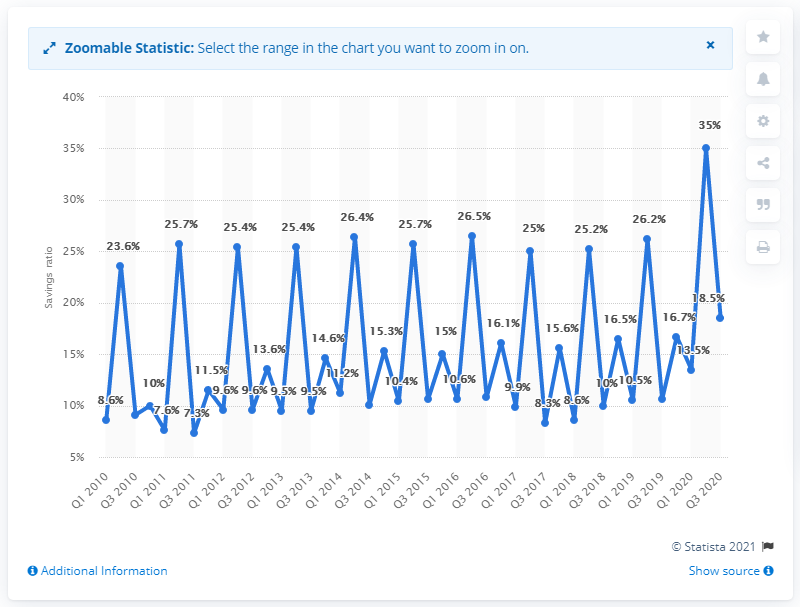Identify some key points in this picture. In the third quarter of 2020, the savings ratio of the Netherlands was 18.5%. 